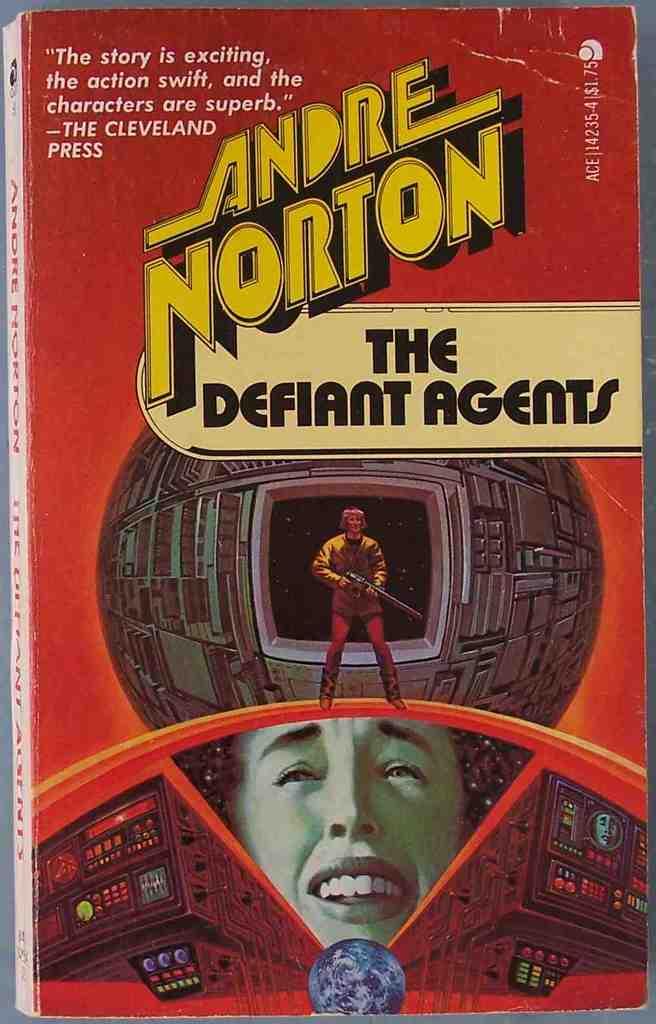Who wrote this book?
Provide a succinct answer. Andre norton. What is the book title?
Make the answer very short. The defiant agents. 